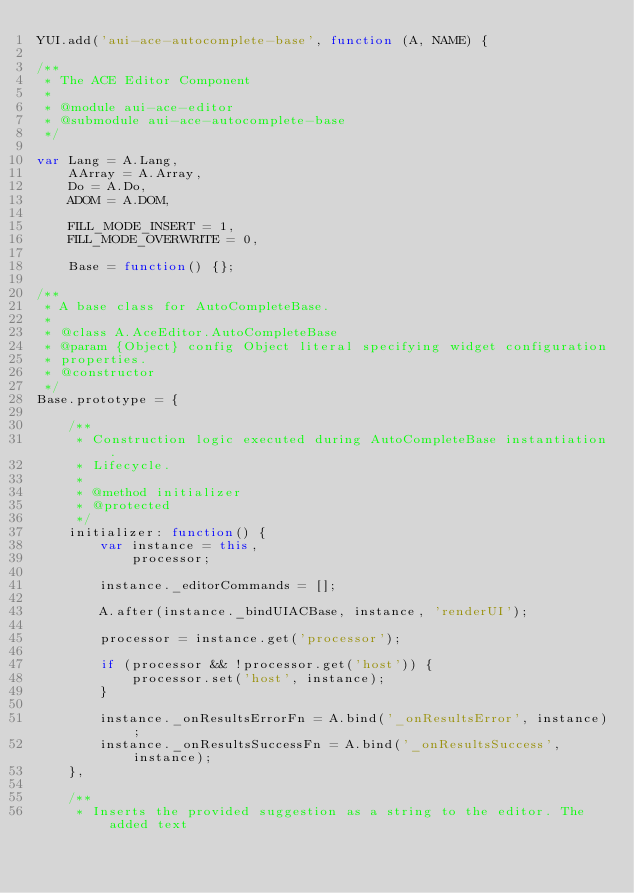<code> <loc_0><loc_0><loc_500><loc_500><_JavaScript_>YUI.add('aui-ace-autocomplete-base', function (A, NAME) {

/**
 * The ACE Editor Component
 *
 * @module aui-ace-editor
 * @submodule aui-ace-autocomplete-base
 */

var Lang = A.Lang,
    AArray = A.Array,
    Do = A.Do,
    ADOM = A.DOM,

    FILL_MODE_INSERT = 1,
    FILL_MODE_OVERWRITE = 0,

    Base = function() {};

/**
 * A base class for AutoCompleteBase.
 *
 * @class A.AceEditor.AutoCompleteBase
 * @param {Object} config Object literal specifying widget configuration
 * properties.
 * @constructor
 */
Base.prototype = {

    /**
     * Construction logic executed during AutoCompleteBase instantiation.
     * Lifecycle.
     *
     * @method initializer
     * @protected
     */
    initializer: function() {
        var instance = this,
            processor;

        instance._editorCommands = [];

        A.after(instance._bindUIACBase, instance, 'renderUI');

        processor = instance.get('processor');

        if (processor && !processor.get('host')) {
            processor.set('host', instance);
        }

        instance._onResultsErrorFn = A.bind('_onResultsError', instance);
        instance._onResultsSuccessFn = A.bind('_onResultsSuccess', instance);
    },

    /**
     * Inserts the provided suggestion as a string to the editor. The added text</code> 